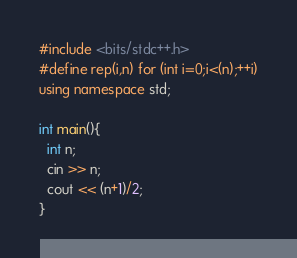Convert code to text. <code><loc_0><loc_0><loc_500><loc_500><_C++_>#include <bits/stdc++.h>
#define rep(i,n) for (int i=0;i<(n);++i)
using namespace std;

int main(){
  int n;
  cin >> n;
  cout << (n+1)/2;
}</code> 